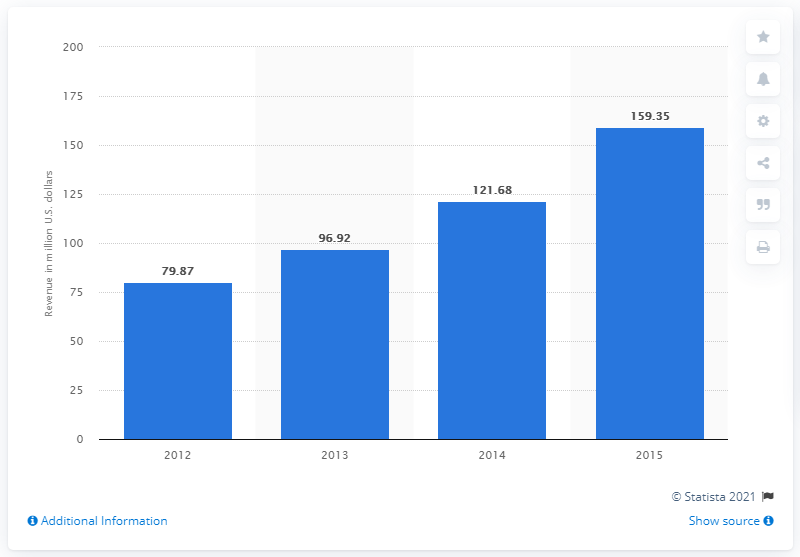Outline some significant characteristics in this image. In 2014, the revenue of World Gym Taiwan was 121.68 million dollars. 